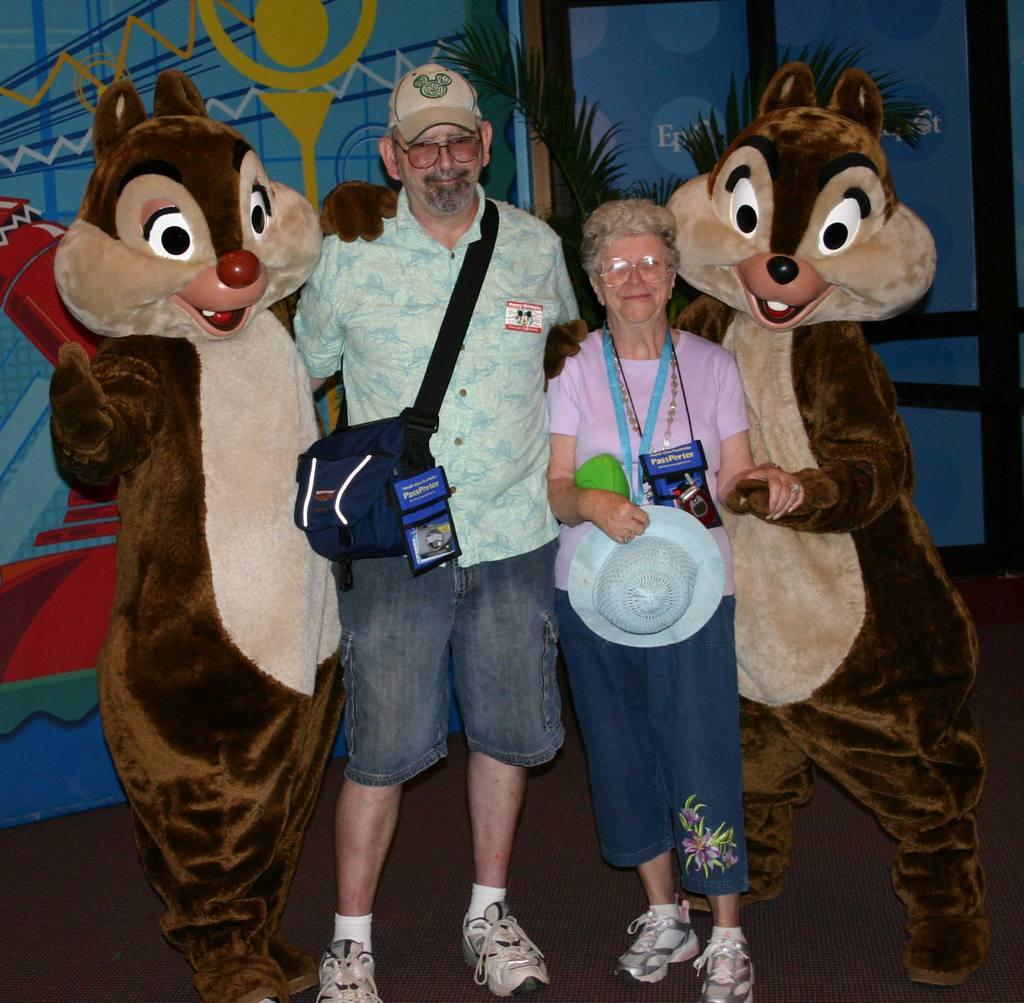Who is present in the image? There is a man and a lady in the image. What are the man and the lady doing in the image? Both the man and the lady are standing and smiling. What other characters can be seen in the image? There are clowns in the image. What can be seen in the background of the image? There is a plant and a wall in the background of the image. What is on the wall in the background? There is a painting on the wall. What type of music is being played by the man in the image? There is no indication of music or any musical instruments in the image. 